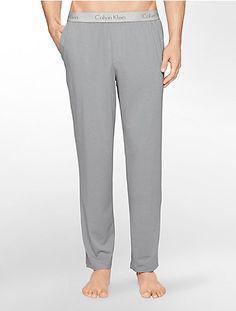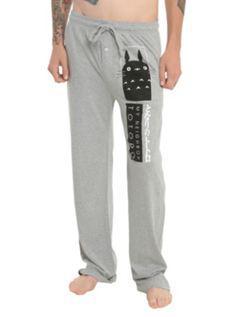The first image is the image on the left, the second image is the image on the right. Examine the images to the left and right. Is the description "There are two pairs of grey athletic pants." accurate? Answer yes or no. Yes. 